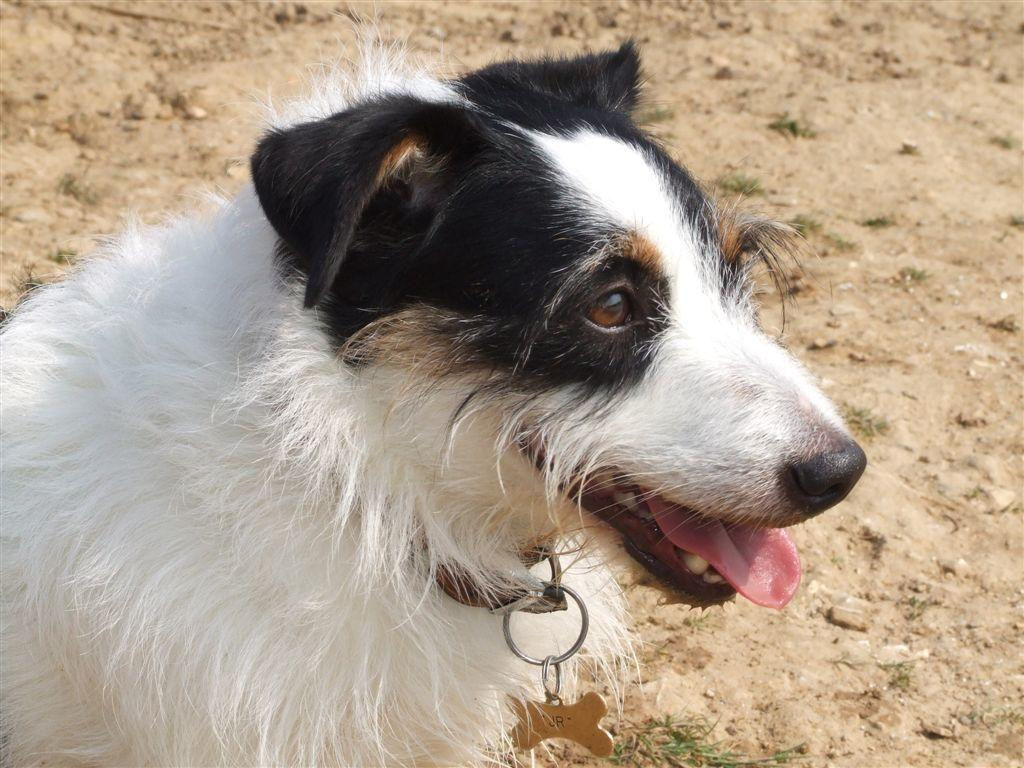What type of animal is in the image? There is a dog in the image. Where is the dog located in the image? The dog is on the ground. Is there anything attached to the dog in the image? Yes, the dog has a chain on it. What scent can be detected coming from the dog in the image? There is no information about the dog's scent in the image, so it cannot be determined. 